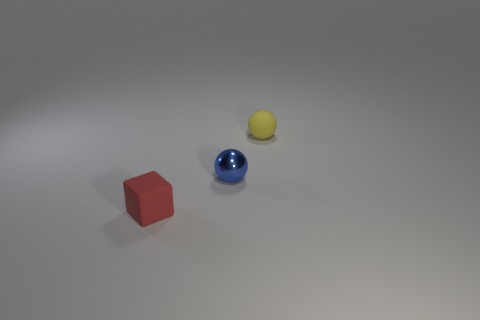Is there a tiny yellow matte ball that is left of the tiny ball that is behind the metallic ball?
Keep it short and to the point. No. How many rubber things are balls or tiny cubes?
Provide a succinct answer. 2. What is the material of the object that is both in front of the small rubber ball and behind the small red block?
Your answer should be compact. Metal. There is a rubber thing to the right of the tiny rubber object in front of the tiny blue thing; is there a tiny yellow rubber ball that is to the right of it?
Make the answer very short. No. Is there any other thing that is made of the same material as the yellow sphere?
Ensure brevity in your answer.  Yes. There is a small thing that is the same material as the cube; what shape is it?
Provide a succinct answer. Sphere. Are there fewer matte balls that are to the left of the blue thing than tiny yellow things in front of the small yellow rubber ball?
Your answer should be very brief. No. What number of tiny objects are either red metal balls or blue shiny objects?
Provide a succinct answer. 1. Do the object that is behind the small metallic object and the tiny matte object that is in front of the tiny rubber sphere have the same shape?
Ensure brevity in your answer.  No. What size is the rubber thing in front of the matte thing that is to the right of the thing in front of the tiny blue ball?
Offer a very short reply. Small. 